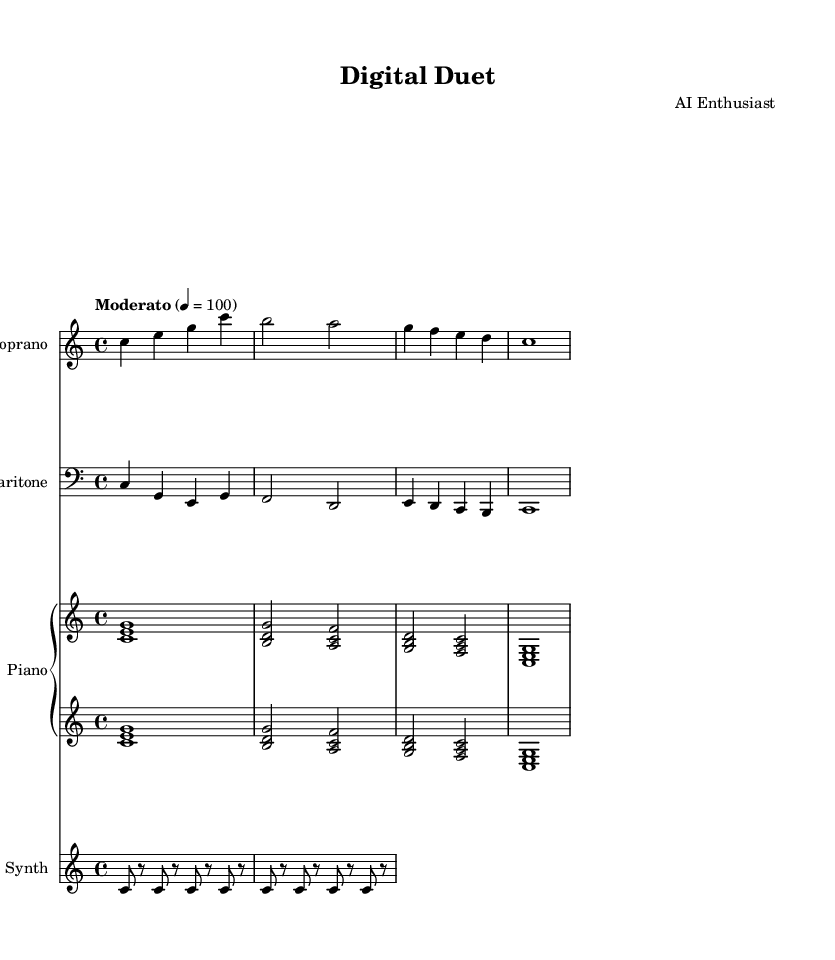What is the key signature of this music? The key signature shown in the staff indicates that it is in C major, as there are no sharps or flats indicated.
Answer: C major What is the time signature of the piece? The time signature is represented by the fraction shown at the beginning of the measure, which is 4/4, indicating four beats per measure and a quarter note gets one beat.
Answer: 4/4 What is the tempo marking for this operatic piece? The tempo marking shown at the beginning specifies "Moderato," indicating a moderate pace, and it's followed by the number 100, indicating the beats per minute.
Answer: Moderato How many verses are sung by the soprano? The soprano part contains one verse, as indicated in the lyrics section under the soprano staff, which is labeled "verse."
Answer: One What do the lyrics in the chorus emphasize? The lyrics in the chorus emphasize the combination of digital and human sounds, as suggested by phrases like "our voices combine" and "blurred line," highlighting the interaction between artificial and human elements.
Answer: Blurred line How is the synthesizer part written in terms of note duration? The synthesizer part consists entirely of eighth notes and rests, as noted by the use of the '8' indicating eighth notes, and rests shown as 'r' in the part.
Answer: Eighth notes What is the overall theme being explored in this opera? The overall theme explored in this opera centers around artificial intelligence and human-computer interaction, as suggested by the lyrics and the title "Digital Duet."
Answer: Artificial intelligence 